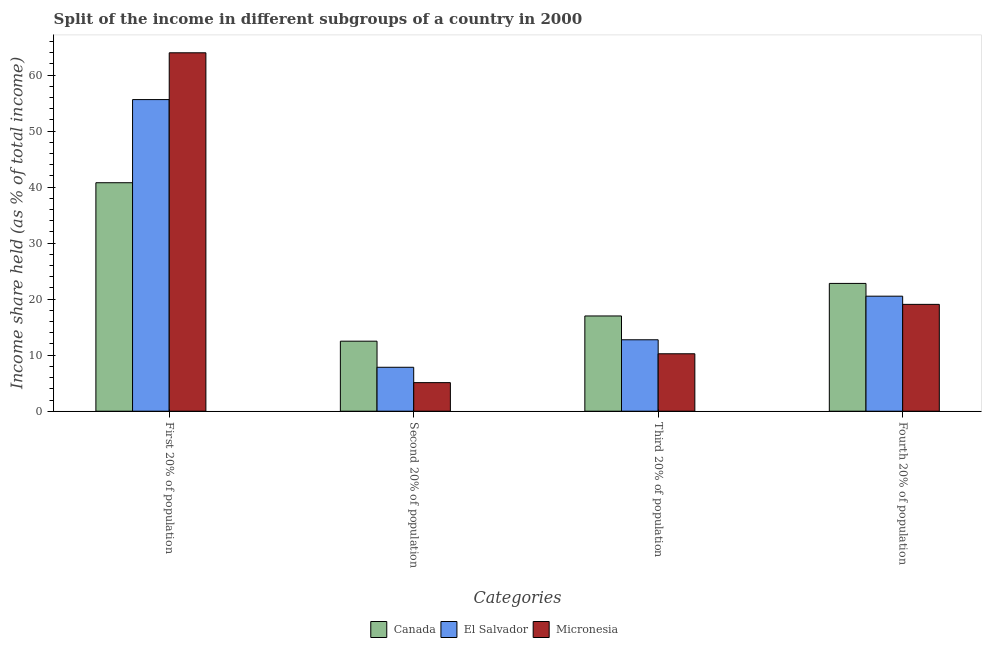Are the number of bars per tick equal to the number of legend labels?
Provide a short and direct response. Yes. Are the number of bars on each tick of the X-axis equal?
Ensure brevity in your answer.  Yes. How many bars are there on the 2nd tick from the left?
Your answer should be very brief. 3. How many bars are there on the 3rd tick from the right?
Your response must be concise. 3. What is the label of the 4th group of bars from the left?
Keep it short and to the point. Fourth 20% of population. What is the share of the income held by third 20% of the population in Micronesia?
Offer a very short reply. 10.25. Across all countries, what is the maximum share of the income held by first 20% of the population?
Give a very brief answer. 63.97. Across all countries, what is the minimum share of the income held by third 20% of the population?
Make the answer very short. 10.25. In which country was the share of the income held by third 20% of the population maximum?
Your response must be concise. Canada. In which country was the share of the income held by third 20% of the population minimum?
Offer a terse response. Micronesia. What is the total share of the income held by fourth 20% of the population in the graph?
Offer a terse response. 62.41. What is the difference between the share of the income held by second 20% of the population in El Salvador and the share of the income held by first 20% of the population in Canada?
Offer a very short reply. -32.94. What is the average share of the income held by third 20% of the population per country?
Your answer should be very brief. 13.33. What is the difference between the share of the income held by third 20% of the population and share of the income held by first 20% of the population in El Salvador?
Offer a terse response. -42.87. In how many countries, is the share of the income held by fourth 20% of the population greater than 42 %?
Your answer should be very brief. 0. What is the ratio of the share of the income held by third 20% of the population in El Salvador to that in Micronesia?
Ensure brevity in your answer.  1.24. Is the share of the income held by fourth 20% of the population in Canada less than that in El Salvador?
Your answer should be very brief. No. Is the difference between the share of the income held by third 20% of the population in Canada and Micronesia greater than the difference between the share of the income held by second 20% of the population in Canada and Micronesia?
Offer a terse response. No. What is the difference between the highest and the second highest share of the income held by fourth 20% of the population?
Provide a succinct answer. 2.28. Is it the case that in every country, the sum of the share of the income held by second 20% of the population and share of the income held by fourth 20% of the population is greater than the sum of share of the income held by third 20% of the population and share of the income held by first 20% of the population?
Keep it short and to the point. Yes. What does the 3rd bar from the left in Second 20% of population represents?
Offer a terse response. Micronesia. What does the 1st bar from the right in Third 20% of population represents?
Make the answer very short. Micronesia. Is it the case that in every country, the sum of the share of the income held by first 20% of the population and share of the income held by second 20% of the population is greater than the share of the income held by third 20% of the population?
Keep it short and to the point. Yes. How many bars are there?
Provide a succinct answer. 12. How many countries are there in the graph?
Offer a very short reply. 3. What is the difference between two consecutive major ticks on the Y-axis?
Ensure brevity in your answer.  10. Does the graph contain any zero values?
Give a very brief answer. No. Does the graph contain grids?
Keep it short and to the point. No. Where does the legend appear in the graph?
Your answer should be compact. Bottom center. How many legend labels are there?
Make the answer very short. 3. What is the title of the graph?
Make the answer very short. Split of the income in different subgroups of a country in 2000. What is the label or title of the X-axis?
Your answer should be compact. Categories. What is the label or title of the Y-axis?
Your answer should be compact. Income share held (as % of total income). What is the Income share held (as % of total income) of Canada in First 20% of population?
Keep it short and to the point. 40.78. What is the Income share held (as % of total income) in El Salvador in First 20% of population?
Your response must be concise. 55.62. What is the Income share held (as % of total income) of Micronesia in First 20% of population?
Give a very brief answer. 63.97. What is the Income share held (as % of total income) of Canada in Second 20% of population?
Offer a terse response. 12.5. What is the Income share held (as % of total income) of El Salvador in Second 20% of population?
Offer a terse response. 7.84. What is the Income share held (as % of total income) of Canada in Third 20% of population?
Offer a very short reply. 17. What is the Income share held (as % of total income) in El Salvador in Third 20% of population?
Offer a terse response. 12.75. What is the Income share held (as % of total income) of Micronesia in Third 20% of population?
Provide a short and direct response. 10.25. What is the Income share held (as % of total income) of Canada in Fourth 20% of population?
Make the answer very short. 22.81. What is the Income share held (as % of total income) in El Salvador in Fourth 20% of population?
Provide a short and direct response. 20.53. What is the Income share held (as % of total income) in Micronesia in Fourth 20% of population?
Keep it short and to the point. 19.07. Across all Categories, what is the maximum Income share held (as % of total income) in Canada?
Offer a terse response. 40.78. Across all Categories, what is the maximum Income share held (as % of total income) in El Salvador?
Keep it short and to the point. 55.62. Across all Categories, what is the maximum Income share held (as % of total income) of Micronesia?
Your answer should be very brief. 63.97. Across all Categories, what is the minimum Income share held (as % of total income) in Canada?
Offer a terse response. 12.5. Across all Categories, what is the minimum Income share held (as % of total income) in El Salvador?
Ensure brevity in your answer.  7.84. What is the total Income share held (as % of total income) of Canada in the graph?
Offer a terse response. 93.09. What is the total Income share held (as % of total income) in El Salvador in the graph?
Your answer should be compact. 96.74. What is the total Income share held (as % of total income) of Micronesia in the graph?
Give a very brief answer. 98.39. What is the difference between the Income share held (as % of total income) of Canada in First 20% of population and that in Second 20% of population?
Make the answer very short. 28.28. What is the difference between the Income share held (as % of total income) of El Salvador in First 20% of population and that in Second 20% of population?
Ensure brevity in your answer.  47.78. What is the difference between the Income share held (as % of total income) of Micronesia in First 20% of population and that in Second 20% of population?
Provide a short and direct response. 58.87. What is the difference between the Income share held (as % of total income) in Canada in First 20% of population and that in Third 20% of population?
Your answer should be very brief. 23.78. What is the difference between the Income share held (as % of total income) in El Salvador in First 20% of population and that in Third 20% of population?
Your answer should be very brief. 42.87. What is the difference between the Income share held (as % of total income) of Micronesia in First 20% of population and that in Third 20% of population?
Your response must be concise. 53.72. What is the difference between the Income share held (as % of total income) of Canada in First 20% of population and that in Fourth 20% of population?
Your response must be concise. 17.97. What is the difference between the Income share held (as % of total income) of El Salvador in First 20% of population and that in Fourth 20% of population?
Provide a succinct answer. 35.09. What is the difference between the Income share held (as % of total income) in Micronesia in First 20% of population and that in Fourth 20% of population?
Ensure brevity in your answer.  44.9. What is the difference between the Income share held (as % of total income) of Canada in Second 20% of population and that in Third 20% of population?
Provide a short and direct response. -4.5. What is the difference between the Income share held (as % of total income) of El Salvador in Second 20% of population and that in Third 20% of population?
Keep it short and to the point. -4.91. What is the difference between the Income share held (as % of total income) of Micronesia in Second 20% of population and that in Third 20% of population?
Your answer should be very brief. -5.15. What is the difference between the Income share held (as % of total income) of Canada in Second 20% of population and that in Fourth 20% of population?
Provide a succinct answer. -10.31. What is the difference between the Income share held (as % of total income) in El Salvador in Second 20% of population and that in Fourth 20% of population?
Offer a terse response. -12.69. What is the difference between the Income share held (as % of total income) of Micronesia in Second 20% of population and that in Fourth 20% of population?
Provide a succinct answer. -13.97. What is the difference between the Income share held (as % of total income) in Canada in Third 20% of population and that in Fourth 20% of population?
Your response must be concise. -5.81. What is the difference between the Income share held (as % of total income) of El Salvador in Third 20% of population and that in Fourth 20% of population?
Your answer should be very brief. -7.78. What is the difference between the Income share held (as % of total income) in Micronesia in Third 20% of population and that in Fourth 20% of population?
Provide a succinct answer. -8.82. What is the difference between the Income share held (as % of total income) of Canada in First 20% of population and the Income share held (as % of total income) of El Salvador in Second 20% of population?
Make the answer very short. 32.94. What is the difference between the Income share held (as % of total income) of Canada in First 20% of population and the Income share held (as % of total income) of Micronesia in Second 20% of population?
Make the answer very short. 35.68. What is the difference between the Income share held (as % of total income) in El Salvador in First 20% of population and the Income share held (as % of total income) in Micronesia in Second 20% of population?
Offer a very short reply. 50.52. What is the difference between the Income share held (as % of total income) of Canada in First 20% of population and the Income share held (as % of total income) of El Salvador in Third 20% of population?
Offer a very short reply. 28.03. What is the difference between the Income share held (as % of total income) in Canada in First 20% of population and the Income share held (as % of total income) in Micronesia in Third 20% of population?
Offer a very short reply. 30.53. What is the difference between the Income share held (as % of total income) in El Salvador in First 20% of population and the Income share held (as % of total income) in Micronesia in Third 20% of population?
Keep it short and to the point. 45.37. What is the difference between the Income share held (as % of total income) in Canada in First 20% of population and the Income share held (as % of total income) in El Salvador in Fourth 20% of population?
Offer a very short reply. 20.25. What is the difference between the Income share held (as % of total income) of Canada in First 20% of population and the Income share held (as % of total income) of Micronesia in Fourth 20% of population?
Give a very brief answer. 21.71. What is the difference between the Income share held (as % of total income) in El Salvador in First 20% of population and the Income share held (as % of total income) in Micronesia in Fourth 20% of population?
Offer a terse response. 36.55. What is the difference between the Income share held (as % of total income) in Canada in Second 20% of population and the Income share held (as % of total income) in El Salvador in Third 20% of population?
Give a very brief answer. -0.25. What is the difference between the Income share held (as % of total income) in Canada in Second 20% of population and the Income share held (as % of total income) in Micronesia in Third 20% of population?
Offer a terse response. 2.25. What is the difference between the Income share held (as % of total income) of El Salvador in Second 20% of population and the Income share held (as % of total income) of Micronesia in Third 20% of population?
Give a very brief answer. -2.41. What is the difference between the Income share held (as % of total income) of Canada in Second 20% of population and the Income share held (as % of total income) of El Salvador in Fourth 20% of population?
Your answer should be very brief. -8.03. What is the difference between the Income share held (as % of total income) of Canada in Second 20% of population and the Income share held (as % of total income) of Micronesia in Fourth 20% of population?
Your answer should be very brief. -6.57. What is the difference between the Income share held (as % of total income) in El Salvador in Second 20% of population and the Income share held (as % of total income) in Micronesia in Fourth 20% of population?
Your response must be concise. -11.23. What is the difference between the Income share held (as % of total income) of Canada in Third 20% of population and the Income share held (as % of total income) of El Salvador in Fourth 20% of population?
Provide a succinct answer. -3.53. What is the difference between the Income share held (as % of total income) of Canada in Third 20% of population and the Income share held (as % of total income) of Micronesia in Fourth 20% of population?
Ensure brevity in your answer.  -2.07. What is the difference between the Income share held (as % of total income) in El Salvador in Third 20% of population and the Income share held (as % of total income) in Micronesia in Fourth 20% of population?
Ensure brevity in your answer.  -6.32. What is the average Income share held (as % of total income) in Canada per Categories?
Provide a succinct answer. 23.27. What is the average Income share held (as % of total income) in El Salvador per Categories?
Offer a very short reply. 24.18. What is the average Income share held (as % of total income) of Micronesia per Categories?
Make the answer very short. 24.6. What is the difference between the Income share held (as % of total income) in Canada and Income share held (as % of total income) in El Salvador in First 20% of population?
Your answer should be compact. -14.84. What is the difference between the Income share held (as % of total income) in Canada and Income share held (as % of total income) in Micronesia in First 20% of population?
Keep it short and to the point. -23.19. What is the difference between the Income share held (as % of total income) in El Salvador and Income share held (as % of total income) in Micronesia in First 20% of population?
Your answer should be compact. -8.35. What is the difference between the Income share held (as % of total income) in Canada and Income share held (as % of total income) in El Salvador in Second 20% of population?
Keep it short and to the point. 4.66. What is the difference between the Income share held (as % of total income) in Canada and Income share held (as % of total income) in Micronesia in Second 20% of population?
Keep it short and to the point. 7.4. What is the difference between the Income share held (as % of total income) of El Salvador and Income share held (as % of total income) of Micronesia in Second 20% of population?
Offer a very short reply. 2.74. What is the difference between the Income share held (as % of total income) in Canada and Income share held (as % of total income) in El Salvador in Third 20% of population?
Your answer should be very brief. 4.25. What is the difference between the Income share held (as % of total income) of Canada and Income share held (as % of total income) of Micronesia in Third 20% of population?
Keep it short and to the point. 6.75. What is the difference between the Income share held (as % of total income) in El Salvador and Income share held (as % of total income) in Micronesia in Third 20% of population?
Provide a succinct answer. 2.5. What is the difference between the Income share held (as % of total income) of Canada and Income share held (as % of total income) of El Salvador in Fourth 20% of population?
Provide a succinct answer. 2.28. What is the difference between the Income share held (as % of total income) of Canada and Income share held (as % of total income) of Micronesia in Fourth 20% of population?
Give a very brief answer. 3.74. What is the difference between the Income share held (as % of total income) in El Salvador and Income share held (as % of total income) in Micronesia in Fourth 20% of population?
Keep it short and to the point. 1.46. What is the ratio of the Income share held (as % of total income) of Canada in First 20% of population to that in Second 20% of population?
Give a very brief answer. 3.26. What is the ratio of the Income share held (as % of total income) of El Salvador in First 20% of population to that in Second 20% of population?
Your answer should be compact. 7.09. What is the ratio of the Income share held (as % of total income) in Micronesia in First 20% of population to that in Second 20% of population?
Offer a terse response. 12.54. What is the ratio of the Income share held (as % of total income) of Canada in First 20% of population to that in Third 20% of population?
Offer a terse response. 2.4. What is the ratio of the Income share held (as % of total income) in El Salvador in First 20% of population to that in Third 20% of population?
Your answer should be very brief. 4.36. What is the ratio of the Income share held (as % of total income) of Micronesia in First 20% of population to that in Third 20% of population?
Offer a terse response. 6.24. What is the ratio of the Income share held (as % of total income) in Canada in First 20% of population to that in Fourth 20% of population?
Offer a very short reply. 1.79. What is the ratio of the Income share held (as % of total income) in El Salvador in First 20% of population to that in Fourth 20% of population?
Ensure brevity in your answer.  2.71. What is the ratio of the Income share held (as % of total income) in Micronesia in First 20% of population to that in Fourth 20% of population?
Ensure brevity in your answer.  3.35. What is the ratio of the Income share held (as % of total income) in Canada in Second 20% of population to that in Third 20% of population?
Provide a short and direct response. 0.74. What is the ratio of the Income share held (as % of total income) of El Salvador in Second 20% of population to that in Third 20% of population?
Ensure brevity in your answer.  0.61. What is the ratio of the Income share held (as % of total income) in Micronesia in Second 20% of population to that in Third 20% of population?
Keep it short and to the point. 0.5. What is the ratio of the Income share held (as % of total income) of Canada in Second 20% of population to that in Fourth 20% of population?
Offer a very short reply. 0.55. What is the ratio of the Income share held (as % of total income) in El Salvador in Second 20% of population to that in Fourth 20% of population?
Offer a terse response. 0.38. What is the ratio of the Income share held (as % of total income) in Micronesia in Second 20% of population to that in Fourth 20% of population?
Your answer should be compact. 0.27. What is the ratio of the Income share held (as % of total income) in Canada in Third 20% of population to that in Fourth 20% of population?
Provide a succinct answer. 0.75. What is the ratio of the Income share held (as % of total income) in El Salvador in Third 20% of population to that in Fourth 20% of population?
Ensure brevity in your answer.  0.62. What is the ratio of the Income share held (as % of total income) of Micronesia in Third 20% of population to that in Fourth 20% of population?
Ensure brevity in your answer.  0.54. What is the difference between the highest and the second highest Income share held (as % of total income) in Canada?
Ensure brevity in your answer.  17.97. What is the difference between the highest and the second highest Income share held (as % of total income) in El Salvador?
Offer a very short reply. 35.09. What is the difference between the highest and the second highest Income share held (as % of total income) in Micronesia?
Your answer should be compact. 44.9. What is the difference between the highest and the lowest Income share held (as % of total income) in Canada?
Give a very brief answer. 28.28. What is the difference between the highest and the lowest Income share held (as % of total income) in El Salvador?
Keep it short and to the point. 47.78. What is the difference between the highest and the lowest Income share held (as % of total income) in Micronesia?
Your response must be concise. 58.87. 